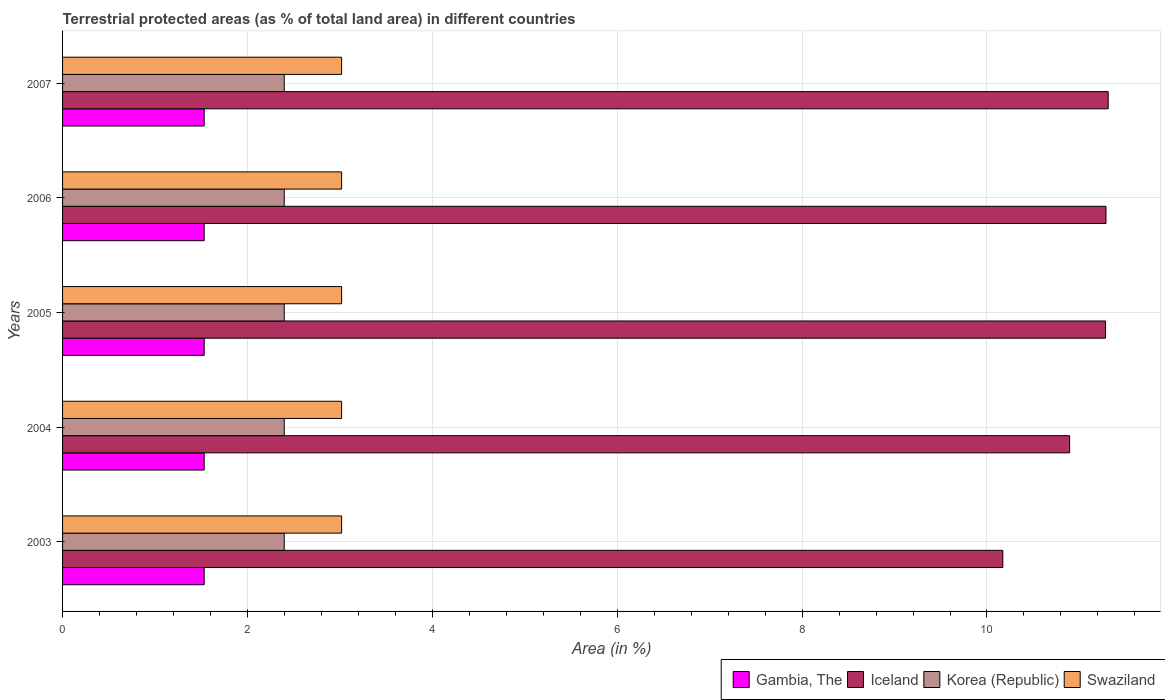How many groups of bars are there?
Offer a very short reply. 5. Are the number of bars per tick equal to the number of legend labels?
Ensure brevity in your answer.  Yes. How many bars are there on the 3rd tick from the bottom?
Give a very brief answer. 4. What is the percentage of terrestrial protected land in Swaziland in 2007?
Your response must be concise. 3.02. Across all years, what is the maximum percentage of terrestrial protected land in Iceland?
Offer a very short reply. 11.31. Across all years, what is the minimum percentage of terrestrial protected land in Korea (Republic)?
Make the answer very short. 2.4. What is the total percentage of terrestrial protected land in Swaziland in the graph?
Keep it short and to the point. 15.09. What is the difference between the percentage of terrestrial protected land in Iceland in 2003 and that in 2005?
Provide a succinct answer. -1.11. What is the difference between the percentage of terrestrial protected land in Gambia, The in 2006 and the percentage of terrestrial protected land in Iceland in 2005?
Your response must be concise. -9.75. What is the average percentage of terrestrial protected land in Gambia, The per year?
Offer a very short reply. 1.53. In the year 2003, what is the difference between the percentage of terrestrial protected land in Gambia, The and percentage of terrestrial protected land in Swaziland?
Your answer should be compact. -1.49. In how many years, is the percentage of terrestrial protected land in Korea (Republic) greater than 6 %?
Make the answer very short. 0. What is the ratio of the percentage of terrestrial protected land in Iceland in 2003 to that in 2005?
Your answer should be very brief. 0.9. Is the percentage of terrestrial protected land in Korea (Republic) in 2006 less than that in 2007?
Give a very brief answer. No. Is the difference between the percentage of terrestrial protected land in Gambia, The in 2003 and 2004 greater than the difference between the percentage of terrestrial protected land in Swaziland in 2003 and 2004?
Provide a short and direct response. No. What is the difference between the highest and the second highest percentage of terrestrial protected land in Iceland?
Keep it short and to the point. 0.02. What is the difference between the highest and the lowest percentage of terrestrial protected land in Gambia, The?
Keep it short and to the point. 0. Is the sum of the percentage of terrestrial protected land in Korea (Republic) in 2004 and 2007 greater than the maximum percentage of terrestrial protected land in Gambia, The across all years?
Keep it short and to the point. Yes. What does the 4th bar from the top in 2005 represents?
Make the answer very short. Gambia, The. What does the 4th bar from the bottom in 2007 represents?
Provide a succinct answer. Swaziland. Are the values on the major ticks of X-axis written in scientific E-notation?
Provide a succinct answer. No. Does the graph contain grids?
Make the answer very short. Yes. How many legend labels are there?
Your answer should be very brief. 4. What is the title of the graph?
Ensure brevity in your answer.  Terrestrial protected areas (as % of total land area) in different countries. What is the label or title of the X-axis?
Make the answer very short. Area (in %). What is the Area (in %) of Gambia, The in 2003?
Make the answer very short. 1.53. What is the Area (in %) of Iceland in 2003?
Provide a short and direct response. 10.17. What is the Area (in %) of Korea (Republic) in 2003?
Ensure brevity in your answer.  2.4. What is the Area (in %) of Swaziland in 2003?
Provide a succinct answer. 3.02. What is the Area (in %) in Gambia, The in 2004?
Keep it short and to the point. 1.53. What is the Area (in %) in Iceland in 2004?
Give a very brief answer. 10.89. What is the Area (in %) of Korea (Republic) in 2004?
Your response must be concise. 2.4. What is the Area (in %) of Swaziland in 2004?
Offer a terse response. 3.02. What is the Area (in %) in Gambia, The in 2005?
Provide a short and direct response. 1.53. What is the Area (in %) of Iceland in 2005?
Ensure brevity in your answer.  11.28. What is the Area (in %) of Korea (Republic) in 2005?
Ensure brevity in your answer.  2.4. What is the Area (in %) of Swaziland in 2005?
Offer a terse response. 3.02. What is the Area (in %) of Gambia, The in 2006?
Ensure brevity in your answer.  1.53. What is the Area (in %) of Iceland in 2006?
Give a very brief answer. 11.29. What is the Area (in %) of Korea (Republic) in 2006?
Keep it short and to the point. 2.4. What is the Area (in %) in Swaziland in 2006?
Offer a very short reply. 3.02. What is the Area (in %) in Gambia, The in 2007?
Your answer should be compact. 1.53. What is the Area (in %) of Iceland in 2007?
Your answer should be compact. 11.31. What is the Area (in %) of Korea (Republic) in 2007?
Provide a succinct answer. 2.4. What is the Area (in %) in Swaziland in 2007?
Offer a terse response. 3.02. Across all years, what is the maximum Area (in %) of Gambia, The?
Your answer should be compact. 1.53. Across all years, what is the maximum Area (in %) in Iceland?
Provide a succinct answer. 11.31. Across all years, what is the maximum Area (in %) of Korea (Republic)?
Keep it short and to the point. 2.4. Across all years, what is the maximum Area (in %) of Swaziland?
Provide a succinct answer. 3.02. Across all years, what is the minimum Area (in %) in Gambia, The?
Provide a succinct answer. 1.53. Across all years, what is the minimum Area (in %) in Iceland?
Make the answer very short. 10.17. Across all years, what is the minimum Area (in %) in Korea (Republic)?
Make the answer very short. 2.4. Across all years, what is the minimum Area (in %) in Swaziland?
Ensure brevity in your answer.  3.02. What is the total Area (in %) in Gambia, The in the graph?
Make the answer very short. 7.66. What is the total Area (in %) in Iceland in the graph?
Provide a succinct answer. 54.95. What is the total Area (in %) of Korea (Republic) in the graph?
Offer a terse response. 11.99. What is the total Area (in %) of Swaziland in the graph?
Ensure brevity in your answer.  15.09. What is the difference between the Area (in %) in Iceland in 2003 and that in 2004?
Offer a very short reply. -0.72. What is the difference between the Area (in %) in Korea (Republic) in 2003 and that in 2004?
Ensure brevity in your answer.  0. What is the difference between the Area (in %) of Swaziland in 2003 and that in 2004?
Ensure brevity in your answer.  0. What is the difference between the Area (in %) in Gambia, The in 2003 and that in 2005?
Ensure brevity in your answer.  0. What is the difference between the Area (in %) of Iceland in 2003 and that in 2005?
Your response must be concise. -1.11. What is the difference between the Area (in %) in Korea (Republic) in 2003 and that in 2005?
Your answer should be compact. 0. What is the difference between the Area (in %) in Swaziland in 2003 and that in 2005?
Offer a terse response. 0. What is the difference between the Area (in %) in Iceland in 2003 and that in 2006?
Give a very brief answer. -1.12. What is the difference between the Area (in %) of Korea (Republic) in 2003 and that in 2006?
Make the answer very short. 0. What is the difference between the Area (in %) in Swaziland in 2003 and that in 2006?
Your answer should be very brief. 0. What is the difference between the Area (in %) of Iceland in 2003 and that in 2007?
Your response must be concise. -1.14. What is the difference between the Area (in %) in Korea (Republic) in 2003 and that in 2007?
Ensure brevity in your answer.  0. What is the difference between the Area (in %) of Swaziland in 2003 and that in 2007?
Offer a very short reply. 0. What is the difference between the Area (in %) of Gambia, The in 2004 and that in 2005?
Provide a succinct answer. 0. What is the difference between the Area (in %) in Iceland in 2004 and that in 2005?
Give a very brief answer. -0.39. What is the difference between the Area (in %) of Iceland in 2004 and that in 2006?
Your answer should be very brief. -0.39. What is the difference between the Area (in %) in Iceland in 2004 and that in 2007?
Your answer should be compact. -0.42. What is the difference between the Area (in %) in Iceland in 2005 and that in 2006?
Give a very brief answer. -0. What is the difference between the Area (in %) of Gambia, The in 2005 and that in 2007?
Provide a short and direct response. 0. What is the difference between the Area (in %) of Iceland in 2005 and that in 2007?
Keep it short and to the point. -0.03. What is the difference between the Area (in %) in Iceland in 2006 and that in 2007?
Your answer should be compact. -0.02. What is the difference between the Area (in %) of Korea (Republic) in 2006 and that in 2007?
Give a very brief answer. 0. What is the difference between the Area (in %) in Swaziland in 2006 and that in 2007?
Offer a terse response. 0. What is the difference between the Area (in %) in Gambia, The in 2003 and the Area (in %) in Iceland in 2004?
Make the answer very short. -9.36. What is the difference between the Area (in %) in Gambia, The in 2003 and the Area (in %) in Korea (Republic) in 2004?
Your response must be concise. -0.87. What is the difference between the Area (in %) in Gambia, The in 2003 and the Area (in %) in Swaziland in 2004?
Provide a succinct answer. -1.49. What is the difference between the Area (in %) in Iceland in 2003 and the Area (in %) in Korea (Republic) in 2004?
Provide a short and direct response. 7.77. What is the difference between the Area (in %) in Iceland in 2003 and the Area (in %) in Swaziland in 2004?
Provide a short and direct response. 7.15. What is the difference between the Area (in %) of Korea (Republic) in 2003 and the Area (in %) of Swaziland in 2004?
Provide a succinct answer. -0.62. What is the difference between the Area (in %) of Gambia, The in 2003 and the Area (in %) of Iceland in 2005?
Give a very brief answer. -9.75. What is the difference between the Area (in %) in Gambia, The in 2003 and the Area (in %) in Korea (Republic) in 2005?
Provide a short and direct response. -0.87. What is the difference between the Area (in %) of Gambia, The in 2003 and the Area (in %) of Swaziland in 2005?
Make the answer very short. -1.49. What is the difference between the Area (in %) of Iceland in 2003 and the Area (in %) of Korea (Republic) in 2005?
Your answer should be very brief. 7.77. What is the difference between the Area (in %) in Iceland in 2003 and the Area (in %) in Swaziland in 2005?
Your response must be concise. 7.15. What is the difference between the Area (in %) in Korea (Republic) in 2003 and the Area (in %) in Swaziland in 2005?
Provide a succinct answer. -0.62. What is the difference between the Area (in %) in Gambia, The in 2003 and the Area (in %) in Iceland in 2006?
Give a very brief answer. -9.76. What is the difference between the Area (in %) in Gambia, The in 2003 and the Area (in %) in Korea (Republic) in 2006?
Keep it short and to the point. -0.87. What is the difference between the Area (in %) in Gambia, The in 2003 and the Area (in %) in Swaziland in 2006?
Your response must be concise. -1.49. What is the difference between the Area (in %) of Iceland in 2003 and the Area (in %) of Korea (Republic) in 2006?
Your answer should be very brief. 7.77. What is the difference between the Area (in %) in Iceland in 2003 and the Area (in %) in Swaziland in 2006?
Ensure brevity in your answer.  7.15. What is the difference between the Area (in %) of Korea (Republic) in 2003 and the Area (in %) of Swaziland in 2006?
Your response must be concise. -0.62. What is the difference between the Area (in %) of Gambia, The in 2003 and the Area (in %) of Iceland in 2007?
Offer a terse response. -9.78. What is the difference between the Area (in %) in Gambia, The in 2003 and the Area (in %) in Korea (Republic) in 2007?
Your answer should be compact. -0.87. What is the difference between the Area (in %) in Gambia, The in 2003 and the Area (in %) in Swaziland in 2007?
Ensure brevity in your answer.  -1.49. What is the difference between the Area (in %) in Iceland in 2003 and the Area (in %) in Korea (Republic) in 2007?
Your answer should be very brief. 7.77. What is the difference between the Area (in %) of Iceland in 2003 and the Area (in %) of Swaziland in 2007?
Offer a terse response. 7.15. What is the difference between the Area (in %) in Korea (Republic) in 2003 and the Area (in %) in Swaziland in 2007?
Provide a short and direct response. -0.62. What is the difference between the Area (in %) in Gambia, The in 2004 and the Area (in %) in Iceland in 2005?
Provide a succinct answer. -9.75. What is the difference between the Area (in %) of Gambia, The in 2004 and the Area (in %) of Korea (Republic) in 2005?
Give a very brief answer. -0.87. What is the difference between the Area (in %) in Gambia, The in 2004 and the Area (in %) in Swaziland in 2005?
Provide a succinct answer. -1.49. What is the difference between the Area (in %) in Iceland in 2004 and the Area (in %) in Korea (Republic) in 2005?
Make the answer very short. 8.5. What is the difference between the Area (in %) of Iceland in 2004 and the Area (in %) of Swaziland in 2005?
Keep it short and to the point. 7.88. What is the difference between the Area (in %) of Korea (Republic) in 2004 and the Area (in %) of Swaziland in 2005?
Make the answer very short. -0.62. What is the difference between the Area (in %) in Gambia, The in 2004 and the Area (in %) in Iceland in 2006?
Your answer should be very brief. -9.76. What is the difference between the Area (in %) of Gambia, The in 2004 and the Area (in %) of Korea (Republic) in 2006?
Ensure brevity in your answer.  -0.87. What is the difference between the Area (in %) in Gambia, The in 2004 and the Area (in %) in Swaziland in 2006?
Offer a terse response. -1.49. What is the difference between the Area (in %) in Iceland in 2004 and the Area (in %) in Korea (Republic) in 2006?
Your response must be concise. 8.5. What is the difference between the Area (in %) of Iceland in 2004 and the Area (in %) of Swaziland in 2006?
Offer a terse response. 7.88. What is the difference between the Area (in %) in Korea (Republic) in 2004 and the Area (in %) in Swaziland in 2006?
Ensure brevity in your answer.  -0.62. What is the difference between the Area (in %) in Gambia, The in 2004 and the Area (in %) in Iceland in 2007?
Offer a terse response. -9.78. What is the difference between the Area (in %) in Gambia, The in 2004 and the Area (in %) in Korea (Republic) in 2007?
Ensure brevity in your answer.  -0.87. What is the difference between the Area (in %) in Gambia, The in 2004 and the Area (in %) in Swaziland in 2007?
Give a very brief answer. -1.49. What is the difference between the Area (in %) of Iceland in 2004 and the Area (in %) of Korea (Republic) in 2007?
Offer a very short reply. 8.5. What is the difference between the Area (in %) in Iceland in 2004 and the Area (in %) in Swaziland in 2007?
Offer a very short reply. 7.88. What is the difference between the Area (in %) of Korea (Republic) in 2004 and the Area (in %) of Swaziland in 2007?
Offer a very short reply. -0.62. What is the difference between the Area (in %) of Gambia, The in 2005 and the Area (in %) of Iceland in 2006?
Your answer should be compact. -9.76. What is the difference between the Area (in %) in Gambia, The in 2005 and the Area (in %) in Korea (Republic) in 2006?
Keep it short and to the point. -0.87. What is the difference between the Area (in %) in Gambia, The in 2005 and the Area (in %) in Swaziland in 2006?
Provide a short and direct response. -1.49. What is the difference between the Area (in %) in Iceland in 2005 and the Area (in %) in Korea (Republic) in 2006?
Your answer should be compact. 8.88. What is the difference between the Area (in %) of Iceland in 2005 and the Area (in %) of Swaziland in 2006?
Your answer should be compact. 8.26. What is the difference between the Area (in %) in Korea (Republic) in 2005 and the Area (in %) in Swaziland in 2006?
Give a very brief answer. -0.62. What is the difference between the Area (in %) in Gambia, The in 2005 and the Area (in %) in Iceland in 2007?
Your answer should be compact. -9.78. What is the difference between the Area (in %) in Gambia, The in 2005 and the Area (in %) in Korea (Republic) in 2007?
Provide a short and direct response. -0.87. What is the difference between the Area (in %) of Gambia, The in 2005 and the Area (in %) of Swaziland in 2007?
Ensure brevity in your answer.  -1.49. What is the difference between the Area (in %) of Iceland in 2005 and the Area (in %) of Korea (Republic) in 2007?
Ensure brevity in your answer.  8.88. What is the difference between the Area (in %) of Iceland in 2005 and the Area (in %) of Swaziland in 2007?
Offer a terse response. 8.26. What is the difference between the Area (in %) of Korea (Republic) in 2005 and the Area (in %) of Swaziland in 2007?
Your answer should be very brief. -0.62. What is the difference between the Area (in %) in Gambia, The in 2006 and the Area (in %) in Iceland in 2007?
Your answer should be very brief. -9.78. What is the difference between the Area (in %) in Gambia, The in 2006 and the Area (in %) in Korea (Republic) in 2007?
Offer a terse response. -0.87. What is the difference between the Area (in %) of Gambia, The in 2006 and the Area (in %) of Swaziland in 2007?
Offer a terse response. -1.49. What is the difference between the Area (in %) of Iceland in 2006 and the Area (in %) of Korea (Republic) in 2007?
Make the answer very short. 8.89. What is the difference between the Area (in %) of Iceland in 2006 and the Area (in %) of Swaziland in 2007?
Offer a terse response. 8.27. What is the difference between the Area (in %) in Korea (Republic) in 2006 and the Area (in %) in Swaziland in 2007?
Your answer should be compact. -0.62. What is the average Area (in %) in Gambia, The per year?
Your response must be concise. 1.53. What is the average Area (in %) of Iceland per year?
Offer a terse response. 10.99. What is the average Area (in %) of Korea (Republic) per year?
Ensure brevity in your answer.  2.4. What is the average Area (in %) in Swaziland per year?
Offer a terse response. 3.02. In the year 2003, what is the difference between the Area (in %) in Gambia, The and Area (in %) in Iceland?
Provide a short and direct response. -8.64. In the year 2003, what is the difference between the Area (in %) of Gambia, The and Area (in %) of Korea (Republic)?
Your answer should be compact. -0.87. In the year 2003, what is the difference between the Area (in %) in Gambia, The and Area (in %) in Swaziland?
Ensure brevity in your answer.  -1.49. In the year 2003, what is the difference between the Area (in %) in Iceland and Area (in %) in Korea (Republic)?
Give a very brief answer. 7.77. In the year 2003, what is the difference between the Area (in %) of Iceland and Area (in %) of Swaziland?
Offer a terse response. 7.15. In the year 2003, what is the difference between the Area (in %) of Korea (Republic) and Area (in %) of Swaziland?
Your response must be concise. -0.62. In the year 2004, what is the difference between the Area (in %) of Gambia, The and Area (in %) of Iceland?
Keep it short and to the point. -9.36. In the year 2004, what is the difference between the Area (in %) of Gambia, The and Area (in %) of Korea (Republic)?
Make the answer very short. -0.87. In the year 2004, what is the difference between the Area (in %) of Gambia, The and Area (in %) of Swaziland?
Your answer should be very brief. -1.49. In the year 2004, what is the difference between the Area (in %) in Iceland and Area (in %) in Korea (Republic)?
Give a very brief answer. 8.5. In the year 2004, what is the difference between the Area (in %) of Iceland and Area (in %) of Swaziland?
Keep it short and to the point. 7.88. In the year 2004, what is the difference between the Area (in %) of Korea (Republic) and Area (in %) of Swaziland?
Ensure brevity in your answer.  -0.62. In the year 2005, what is the difference between the Area (in %) of Gambia, The and Area (in %) of Iceland?
Keep it short and to the point. -9.75. In the year 2005, what is the difference between the Area (in %) in Gambia, The and Area (in %) in Korea (Republic)?
Ensure brevity in your answer.  -0.87. In the year 2005, what is the difference between the Area (in %) of Gambia, The and Area (in %) of Swaziland?
Make the answer very short. -1.49. In the year 2005, what is the difference between the Area (in %) of Iceland and Area (in %) of Korea (Republic)?
Offer a terse response. 8.88. In the year 2005, what is the difference between the Area (in %) in Iceland and Area (in %) in Swaziland?
Your answer should be compact. 8.26. In the year 2005, what is the difference between the Area (in %) in Korea (Republic) and Area (in %) in Swaziland?
Offer a terse response. -0.62. In the year 2006, what is the difference between the Area (in %) of Gambia, The and Area (in %) of Iceland?
Ensure brevity in your answer.  -9.76. In the year 2006, what is the difference between the Area (in %) of Gambia, The and Area (in %) of Korea (Republic)?
Offer a very short reply. -0.87. In the year 2006, what is the difference between the Area (in %) of Gambia, The and Area (in %) of Swaziland?
Ensure brevity in your answer.  -1.49. In the year 2006, what is the difference between the Area (in %) in Iceland and Area (in %) in Korea (Republic)?
Keep it short and to the point. 8.89. In the year 2006, what is the difference between the Area (in %) in Iceland and Area (in %) in Swaziland?
Make the answer very short. 8.27. In the year 2006, what is the difference between the Area (in %) of Korea (Republic) and Area (in %) of Swaziland?
Your response must be concise. -0.62. In the year 2007, what is the difference between the Area (in %) in Gambia, The and Area (in %) in Iceland?
Your response must be concise. -9.78. In the year 2007, what is the difference between the Area (in %) in Gambia, The and Area (in %) in Korea (Republic)?
Make the answer very short. -0.87. In the year 2007, what is the difference between the Area (in %) in Gambia, The and Area (in %) in Swaziland?
Provide a short and direct response. -1.49. In the year 2007, what is the difference between the Area (in %) of Iceland and Area (in %) of Korea (Republic)?
Your answer should be very brief. 8.91. In the year 2007, what is the difference between the Area (in %) in Iceland and Area (in %) in Swaziland?
Give a very brief answer. 8.29. In the year 2007, what is the difference between the Area (in %) in Korea (Republic) and Area (in %) in Swaziland?
Make the answer very short. -0.62. What is the ratio of the Area (in %) of Iceland in 2003 to that in 2004?
Make the answer very short. 0.93. What is the ratio of the Area (in %) of Korea (Republic) in 2003 to that in 2004?
Offer a very short reply. 1. What is the ratio of the Area (in %) in Iceland in 2003 to that in 2005?
Keep it short and to the point. 0.9. What is the ratio of the Area (in %) in Korea (Republic) in 2003 to that in 2005?
Provide a succinct answer. 1. What is the ratio of the Area (in %) of Swaziland in 2003 to that in 2005?
Keep it short and to the point. 1. What is the ratio of the Area (in %) of Iceland in 2003 to that in 2006?
Offer a terse response. 0.9. What is the ratio of the Area (in %) in Korea (Republic) in 2003 to that in 2006?
Make the answer very short. 1. What is the ratio of the Area (in %) in Iceland in 2003 to that in 2007?
Make the answer very short. 0.9. What is the ratio of the Area (in %) in Korea (Republic) in 2003 to that in 2007?
Keep it short and to the point. 1. What is the ratio of the Area (in %) of Gambia, The in 2004 to that in 2005?
Give a very brief answer. 1. What is the ratio of the Area (in %) in Iceland in 2004 to that in 2005?
Your answer should be compact. 0.97. What is the ratio of the Area (in %) of Swaziland in 2004 to that in 2005?
Make the answer very short. 1. What is the ratio of the Area (in %) of Iceland in 2004 to that in 2006?
Offer a very short reply. 0.97. What is the ratio of the Area (in %) in Gambia, The in 2004 to that in 2007?
Make the answer very short. 1. What is the ratio of the Area (in %) of Iceland in 2004 to that in 2007?
Your response must be concise. 0.96. What is the ratio of the Area (in %) in Swaziland in 2004 to that in 2007?
Offer a terse response. 1. What is the ratio of the Area (in %) in Gambia, The in 2005 to that in 2006?
Ensure brevity in your answer.  1. What is the ratio of the Area (in %) of Iceland in 2005 to that in 2006?
Ensure brevity in your answer.  1. What is the ratio of the Area (in %) of Swaziland in 2005 to that in 2006?
Your response must be concise. 1. What is the ratio of the Area (in %) in Iceland in 2005 to that in 2007?
Offer a terse response. 1. What is the ratio of the Area (in %) of Korea (Republic) in 2005 to that in 2007?
Make the answer very short. 1. What is the ratio of the Area (in %) of Swaziland in 2005 to that in 2007?
Offer a very short reply. 1. What is the ratio of the Area (in %) of Gambia, The in 2006 to that in 2007?
Provide a short and direct response. 1. What is the ratio of the Area (in %) in Iceland in 2006 to that in 2007?
Ensure brevity in your answer.  1. What is the ratio of the Area (in %) of Korea (Republic) in 2006 to that in 2007?
Offer a terse response. 1. What is the ratio of the Area (in %) in Swaziland in 2006 to that in 2007?
Provide a succinct answer. 1. What is the difference between the highest and the second highest Area (in %) of Gambia, The?
Your response must be concise. 0. What is the difference between the highest and the second highest Area (in %) in Iceland?
Give a very brief answer. 0.02. What is the difference between the highest and the second highest Area (in %) of Korea (Republic)?
Your answer should be compact. 0. What is the difference between the highest and the second highest Area (in %) in Swaziland?
Offer a very short reply. 0. What is the difference between the highest and the lowest Area (in %) in Iceland?
Your answer should be very brief. 1.14. 